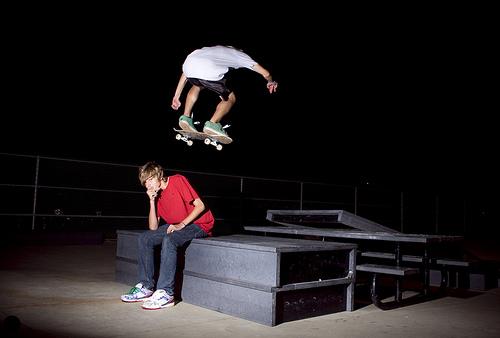Is the boy in red shirt looking at the other person in the picture?
Keep it brief. No. Did the skateboarder jump over the boy?
Write a very short answer. Yes. How well lit is the room?
Write a very short answer. Dark. 